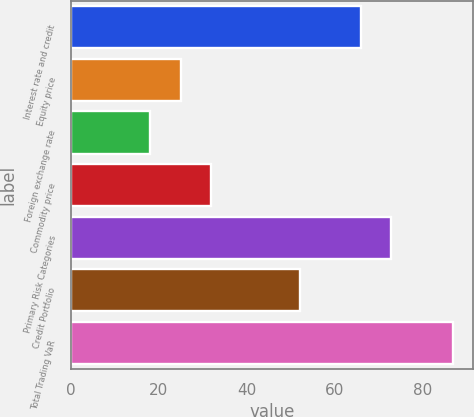Convert chart to OTSL. <chart><loc_0><loc_0><loc_500><loc_500><bar_chart><fcel>Interest rate and credit<fcel>Equity price<fcel>Foreign exchange rate<fcel>Commodity price<fcel>Primary Risk Categories<fcel>Credit Portfolio<fcel>Total Trading VaR<nl><fcel>66<fcel>25<fcel>18<fcel>31.9<fcel>72.9<fcel>52<fcel>87<nl></chart> 